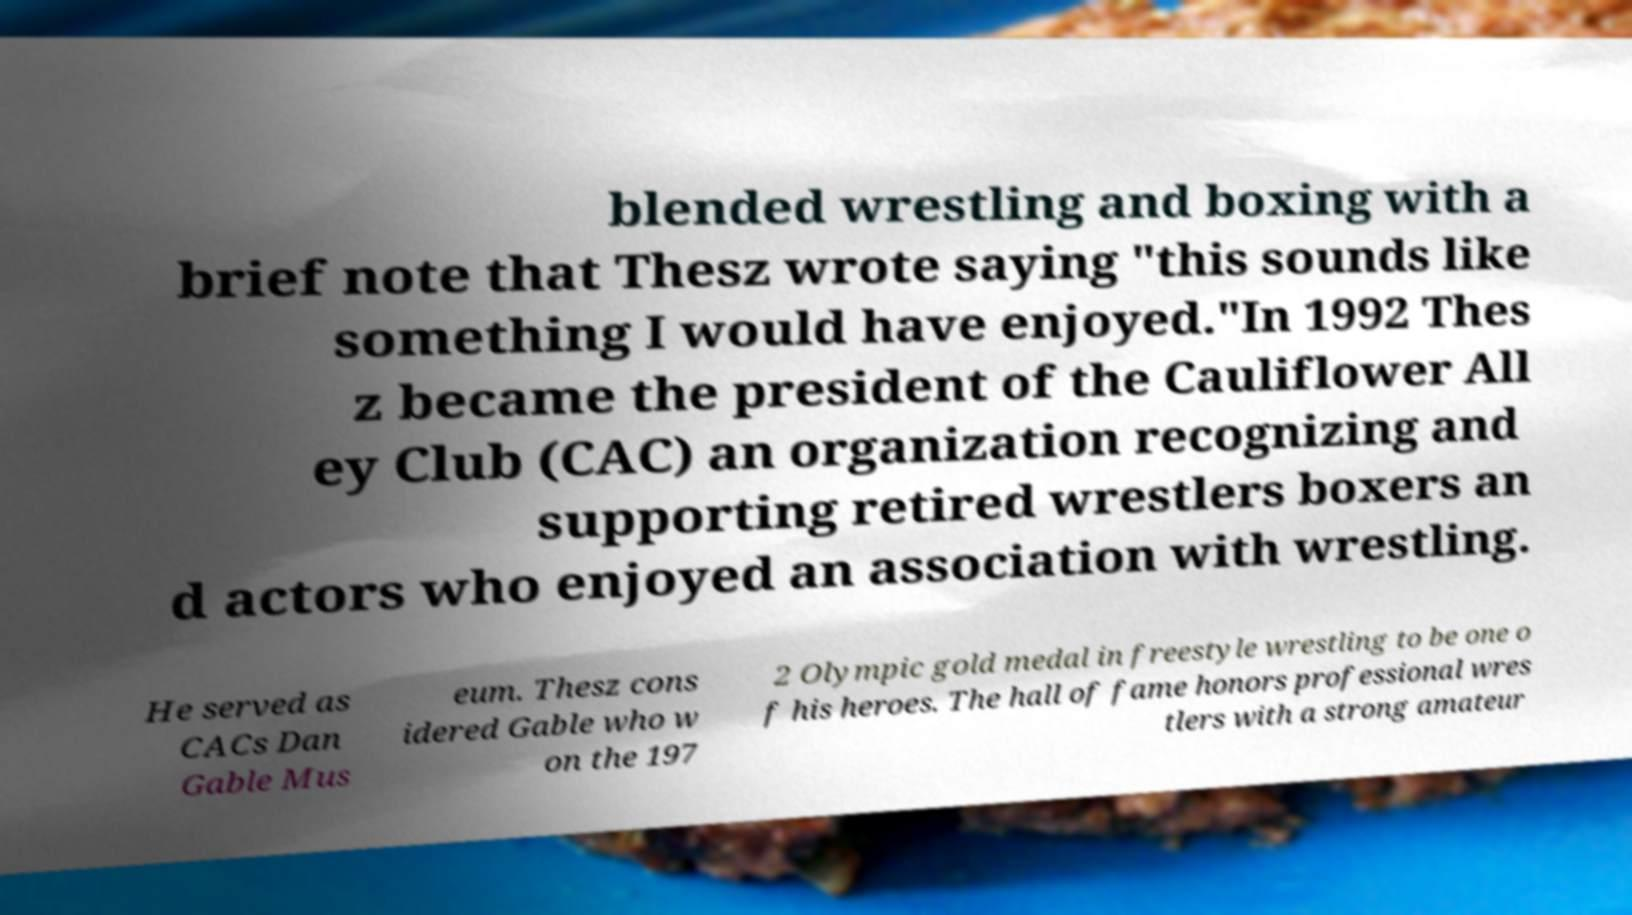Could you extract and type out the text from this image? blended wrestling and boxing with a brief note that Thesz wrote saying "this sounds like something I would have enjoyed."In 1992 Thes z became the president of the Cauliflower All ey Club (CAC) an organization recognizing and supporting retired wrestlers boxers an d actors who enjoyed an association with wrestling. He served as CACs Dan Gable Mus eum. Thesz cons idered Gable who w on the 197 2 Olympic gold medal in freestyle wrestling to be one o f his heroes. The hall of fame honors professional wres tlers with a strong amateur 